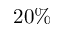<formula> <loc_0><loc_0><loc_500><loc_500>2 0 \%</formula> 